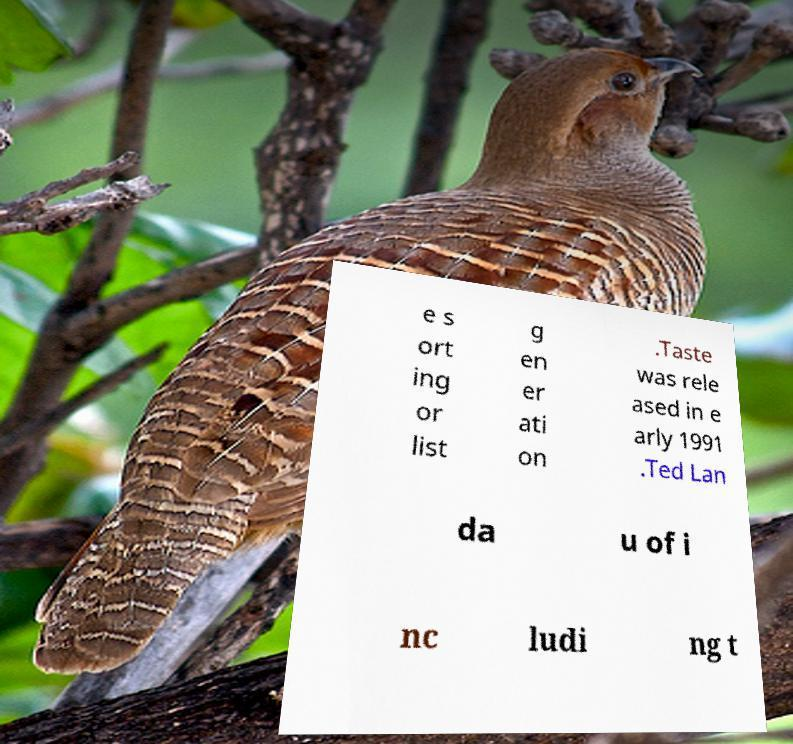Can you read and provide the text displayed in the image?This photo seems to have some interesting text. Can you extract and type it out for me? e s ort ing or list g en er ati on .Taste was rele ased in e arly 1991 .Ted Lan da u of i nc ludi ng t 